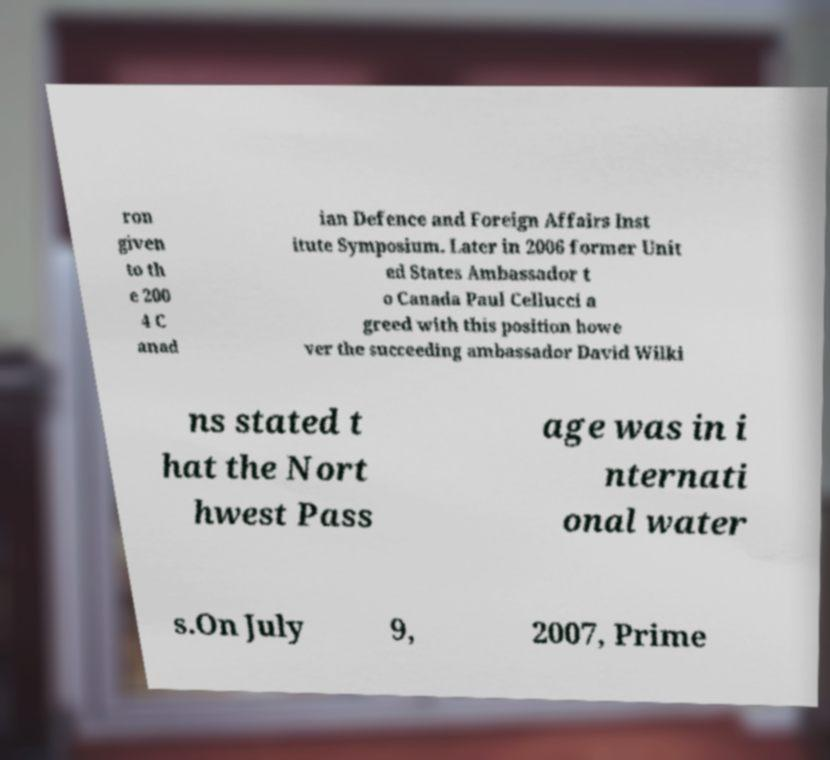Can you accurately transcribe the text from the provided image for me? ron given to th e 200 4 C anad ian Defence and Foreign Affairs Inst itute Symposium. Later in 2006 former Unit ed States Ambassador t o Canada Paul Cellucci a greed with this position howe ver the succeeding ambassador David Wilki ns stated t hat the Nort hwest Pass age was in i nternati onal water s.On July 9, 2007, Prime 